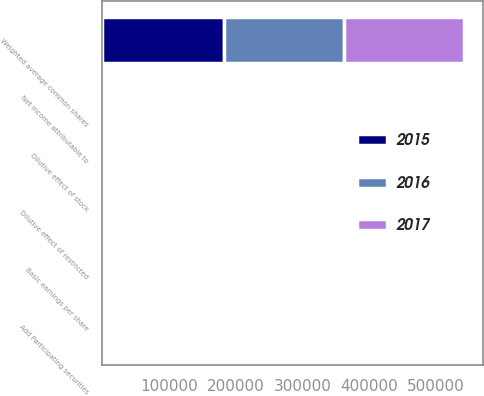Convert chart to OTSL. <chart><loc_0><loc_0><loc_500><loc_500><stacked_bar_chart><ecel><fcel>Net income attributable to<fcel>Weighted average common shares<fcel>Add Participating securities<fcel>Dilutive effect of stock<fcel>Dilutive effect of restricted<fcel>Basic earnings per share<nl><fcel>2017<fcel>331<fcel>180857<fcel>27<fcel>712<fcel>516<fcel>1.84<nl><fcel>2016<fcel>260<fcel>180038<fcel>37<fcel>499<fcel>433<fcel>1.45<nl><fcel>2015<fcel>340<fcel>181737<fcel>39<fcel>465<fcel>379<fcel>1.88<nl></chart> 